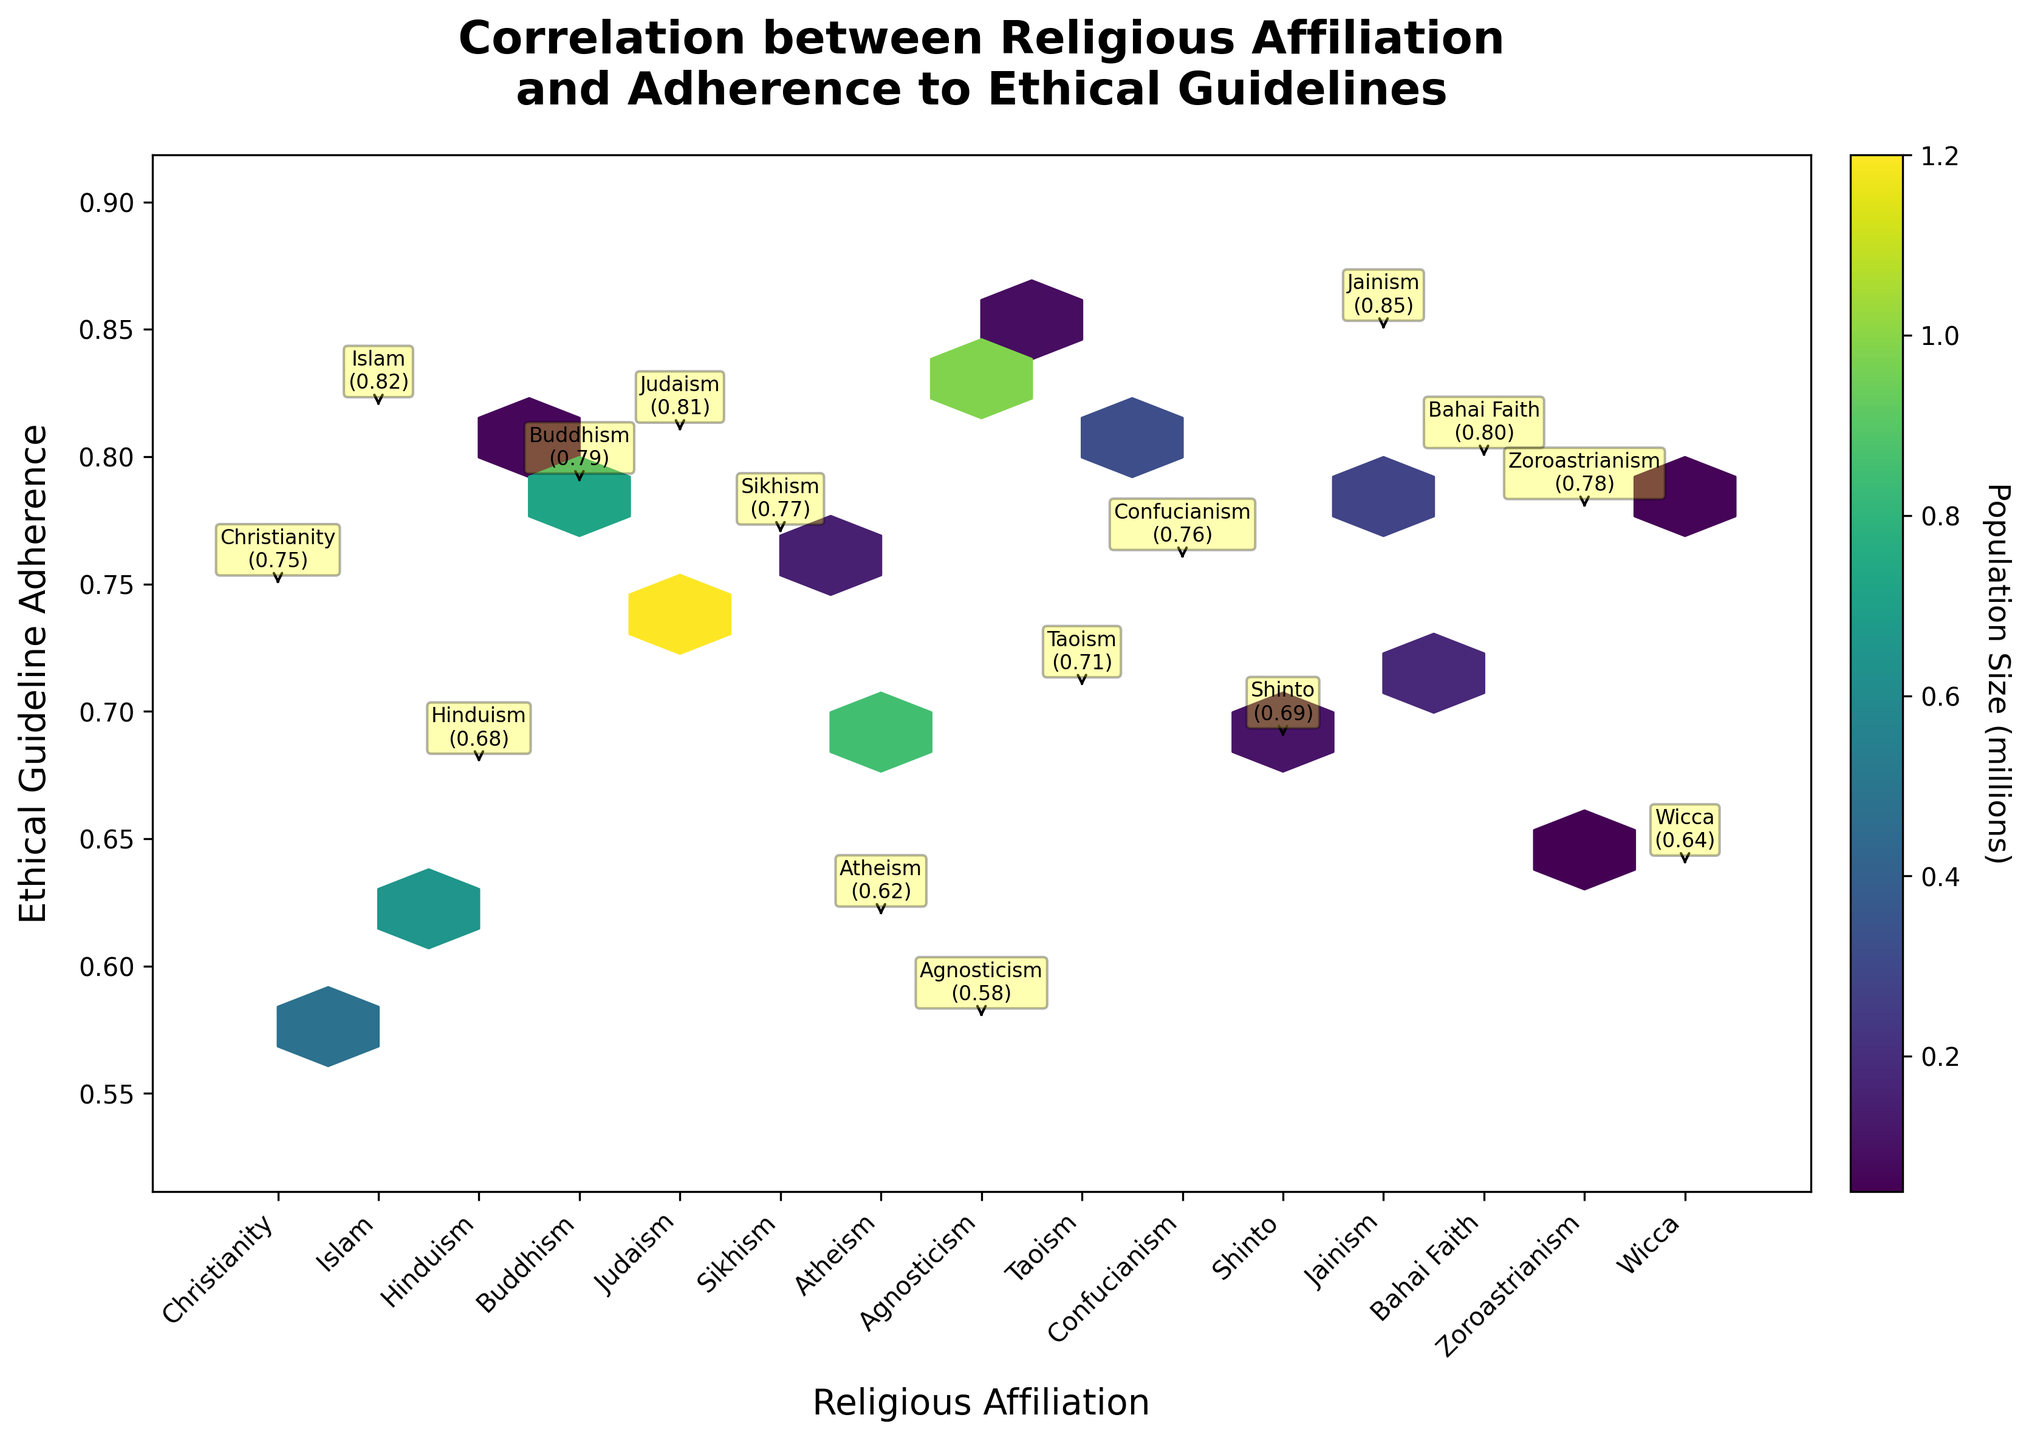What is the title of the figure? The title is at the top of the figure and describes the relationship being investigated.
Answer: Correlation between Religious Affiliation and Adherence to Ethical Guidelines Which religions show the highest ethical guideline adherence? Look at the data labels annotated near the top of the hexbin plot to identify the religions with the highest y-values.
Answer: Jainism How does adherence to ethical guidelines for Christianity compare to that of Buddhism? Compare the y-values for Christianity and Buddhism from the annotated data points.
Answer: Christianity: 0.75, Buddhism: 0.79 Which religious affiliation has the lowest population size? Identify the religion with the smallest area of hexes or the smallest annotated value nearby.
Answer: Wicca What does the color intensity represent in the hexbin plot? Refer to the color bar and its label on the plot to interpret what the colors indicate.
Answer: Population Size (millions) What is the average adherence level of religions with a population size larger than 500,000? Identify religions with populations above 500,000, sum their ethical adherence values, and divide by the count of such religions.
Answer: (0.75 + 0.82 + 0.68 + 0.79 + 0.81 + 0.77 + 0.62) / 7 = 0.748 Which affiliation exhibits a higher ethical adherence, Hinduism or Judaism? Compare the y-values of Hinduism and Judaism from the plot annotations.
Answer: Judaism How do adherence levels among atheists compare to those of agnostics? Compare the Ethical Guideline Adherence values for Atheism and Agnosticism from the plot.
Answer: Atheism: 0.62, Agnosticism: 0.58 What is the median adherence score among all religious affiliations depicted? List all y-values, sort them, and find the middle value(s) to determine the median.
Answer: Median (sorted values: 0.58, 0.62, 0.64, 0.68, 0.69, 0.71, 0.75, 0.76, 0.77, 0.78, 0.79, 0.80, 0.81, 0.82, 0.85) = 0.75 Are there any religious affiliations with adherence levels significantly above the average? Calculate the average adherence level across all affiliations and identify those significantly higher.
Answer: Average: 0.73, Significantly above: Jainism (0.85), Islam (0.82) 